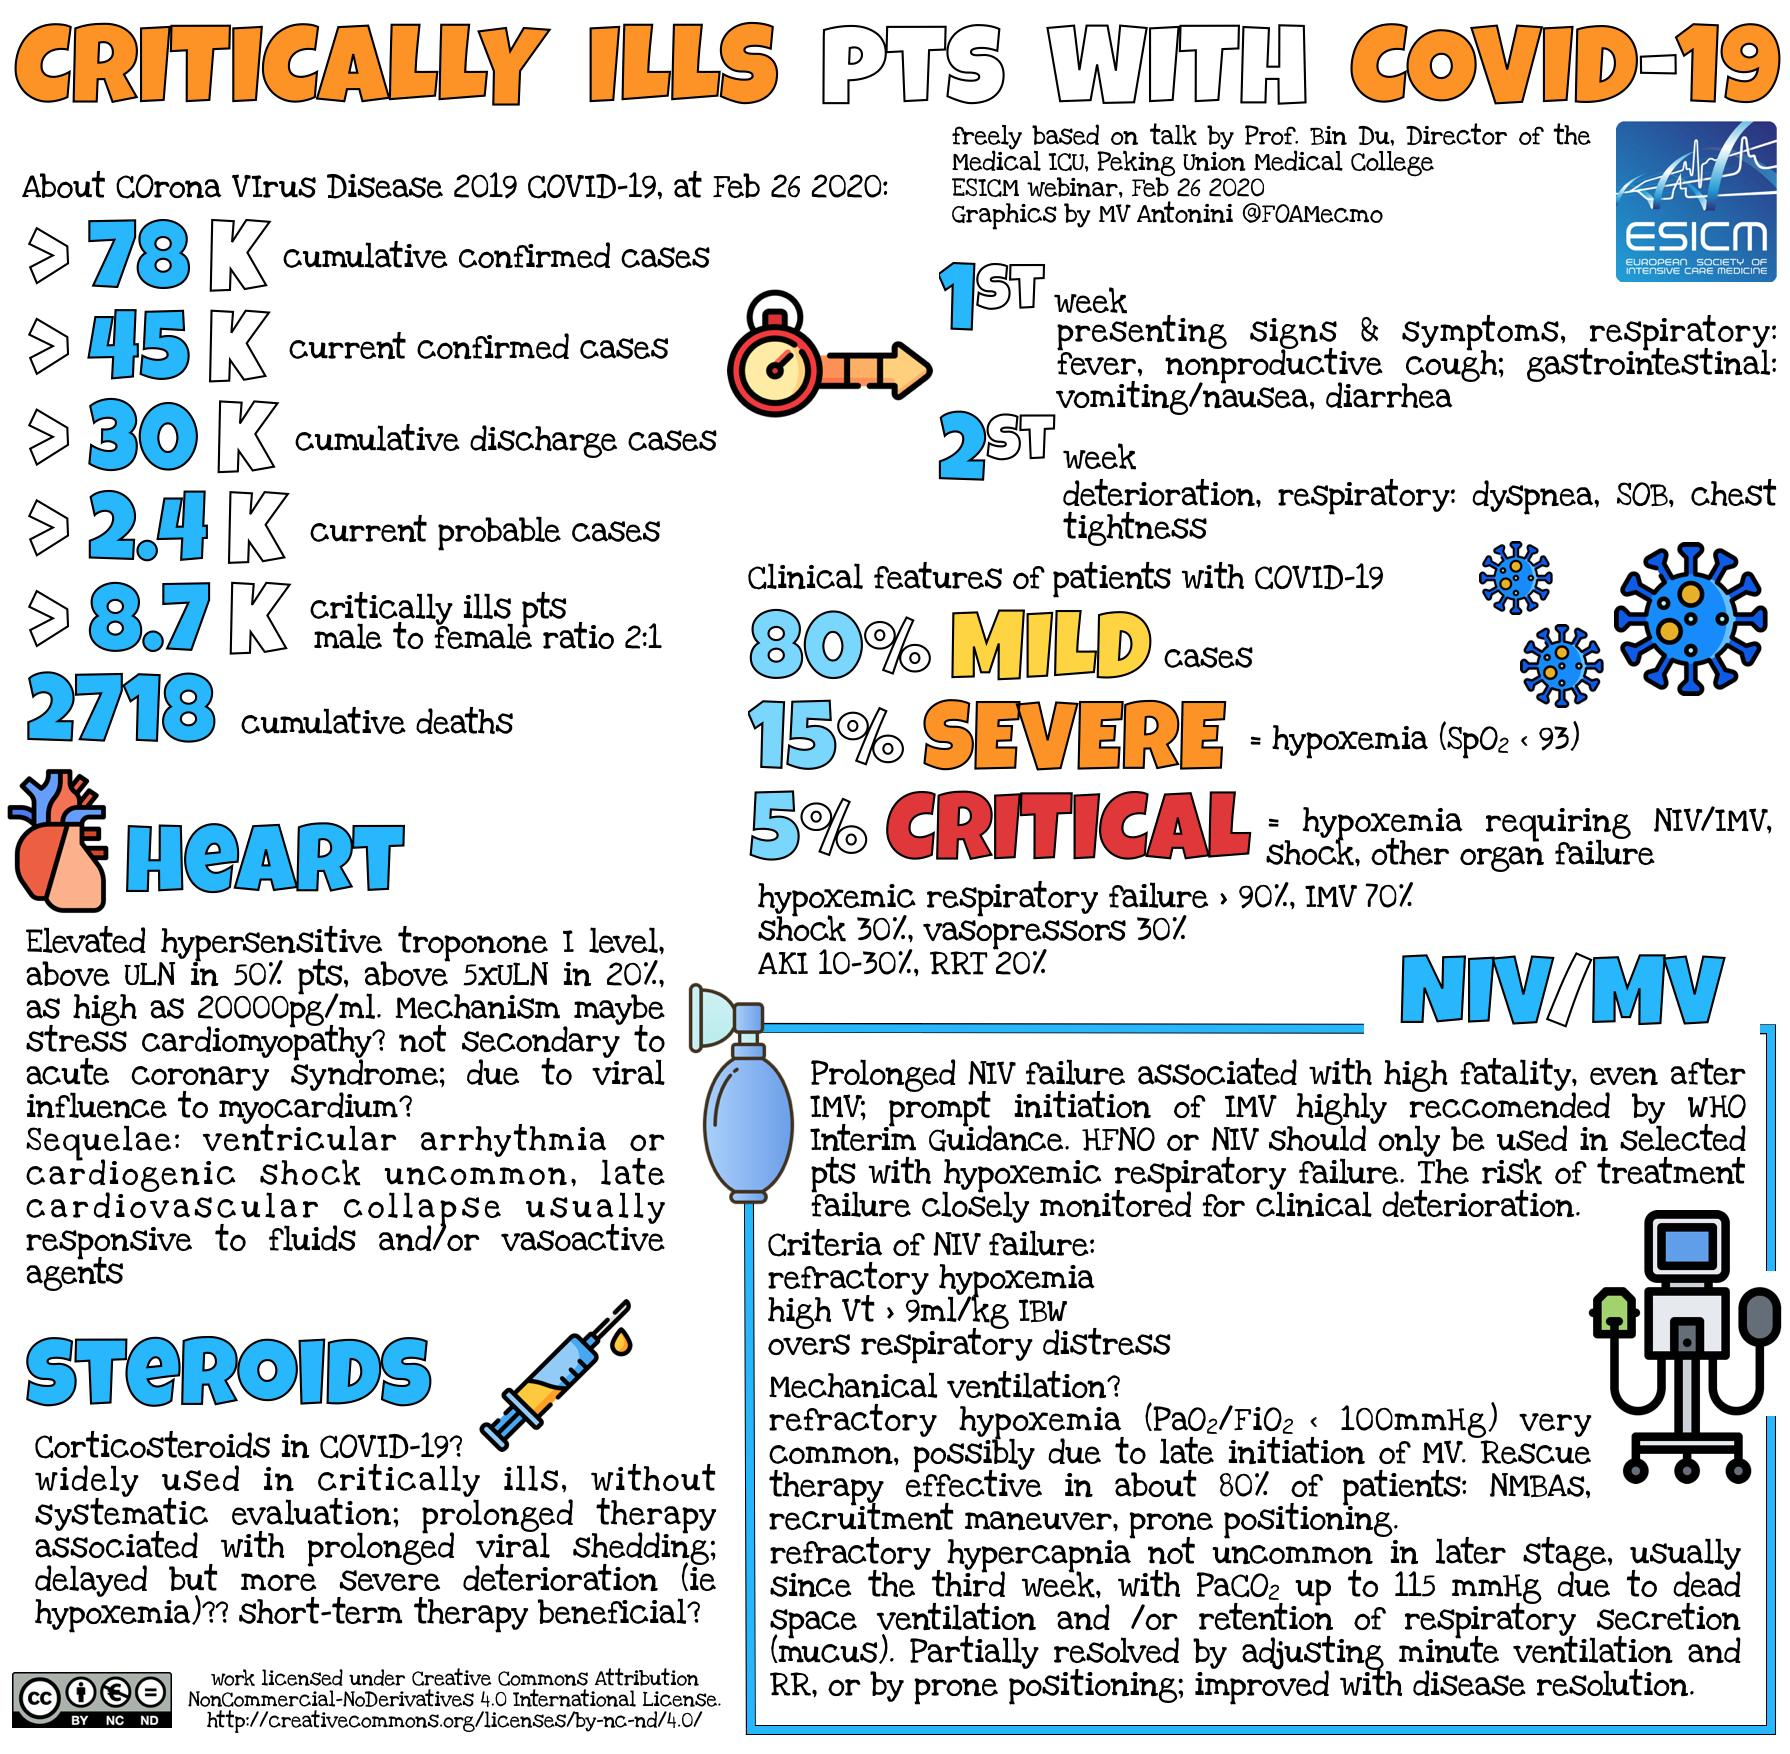List a handful of essential elements in this visual. The total number of people who died due to COVID-19 is 27,183. Of the 8,700 male patients, a total of 5800 are seriously ill and have tested positive for the COVID-19 virus. Out of the total number of female patients who are seriously ill and have tested positive for the COVID-19 virus, approximately 2,900 patients are suffering from the disease. The saturation value of oxygen in acute patients is 93%. Currently, there are over 45,000 seriously ill individuals who are confirmed to be positive for the coronavirus. 